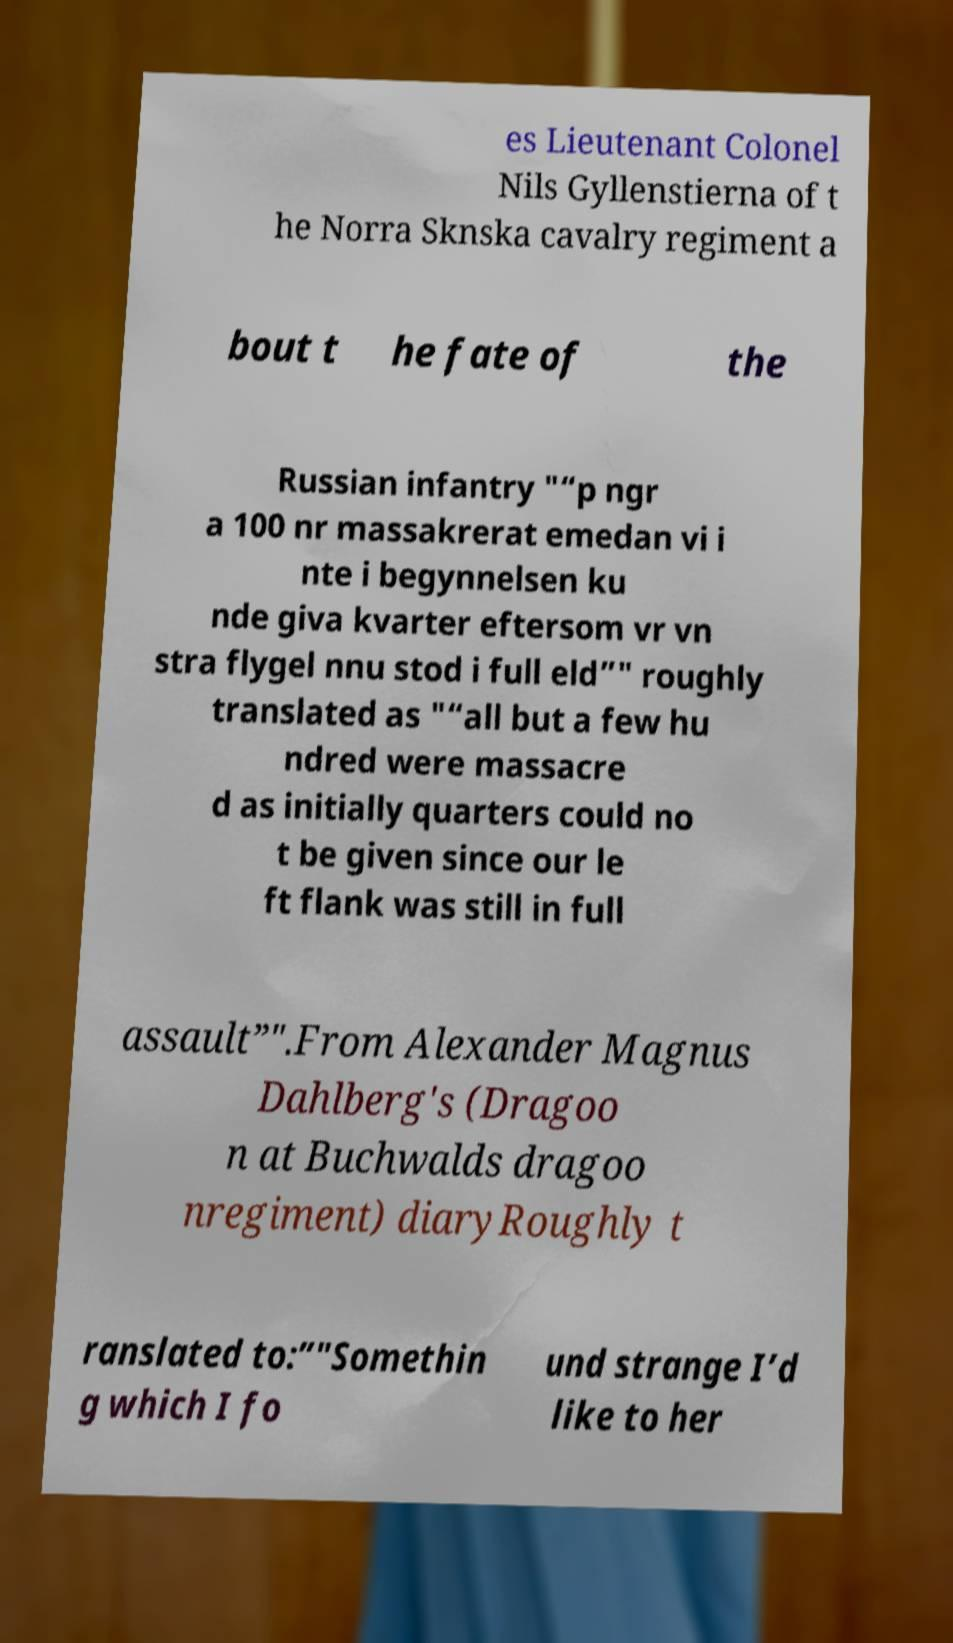There's text embedded in this image that I need extracted. Can you transcribe it verbatim? es Lieutenant Colonel Nils Gyllenstierna of t he Norra Sknska cavalry regiment a bout t he fate of the Russian infantry "“p ngr a 100 nr massakrerat emedan vi i nte i begynnelsen ku nde giva kvarter eftersom vr vn stra flygel nnu stod i full eld”" roughly translated as "“all but a few hu ndred were massacre d as initially quarters could no t be given since our le ft flank was still in full assault”".From Alexander Magnus Dahlberg's (Dragoo n at Buchwalds dragoo nregiment) diaryRoughly t ranslated to:”"Somethin g which I fo und strange I’d like to her 